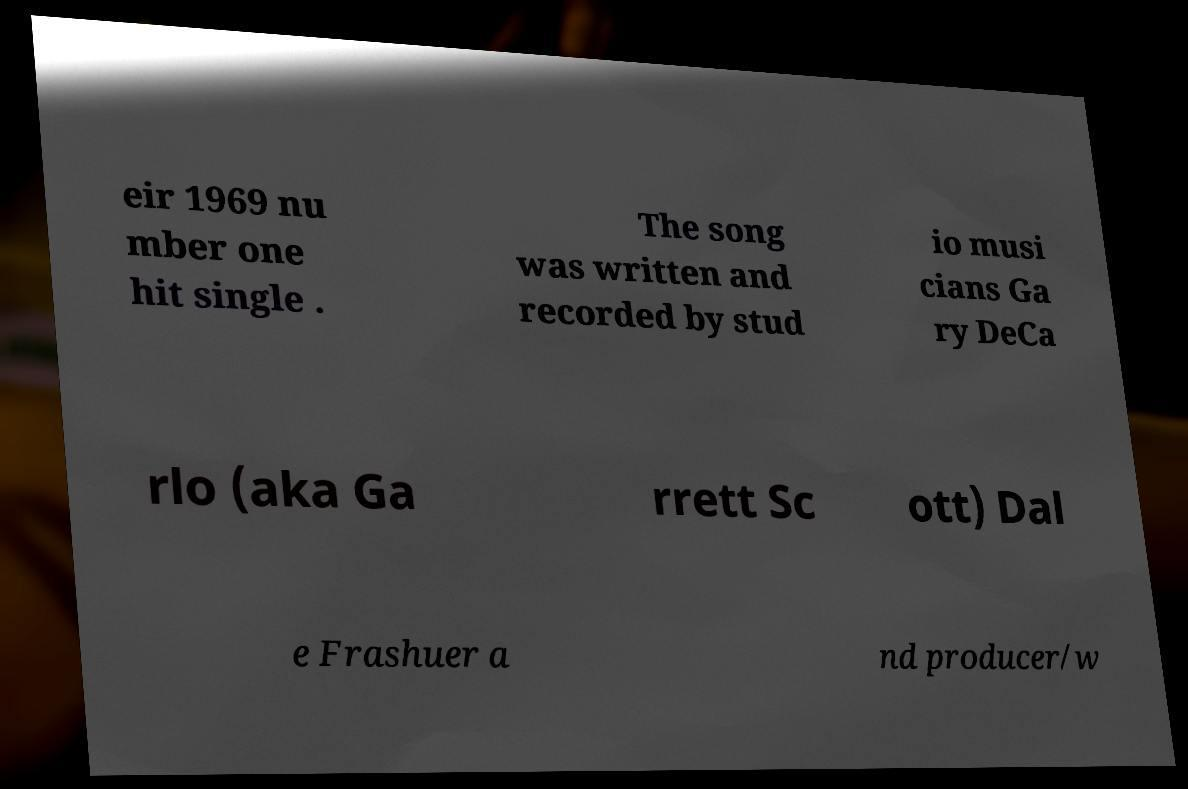Could you assist in decoding the text presented in this image and type it out clearly? eir 1969 nu mber one hit single . The song was written and recorded by stud io musi cians Ga ry DeCa rlo (aka Ga rrett Sc ott) Dal e Frashuer a nd producer/w 